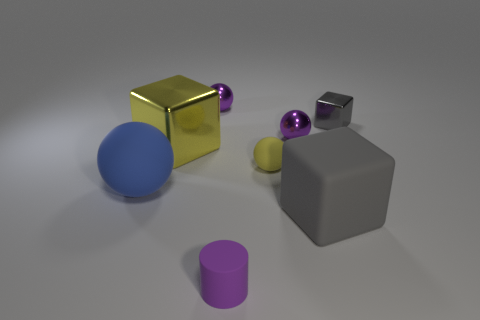Is there a pattern to the arrangement of objects? The objects are arranged in a seemingly random fashion, with different shapes and colors spread across the surface. There's no discernible pattern, but the placement allows for each object to stand out on its own. Could this arrangement serve any practical purpose? It's unclear if there's a practical purpose. If this is an artistic composition, the purpose may be aesthetic, focusing on contrast and variety. However, if it's part of a larger context, like a children's play area, it might also have an educational purpose, teaching about shapes and materials. 